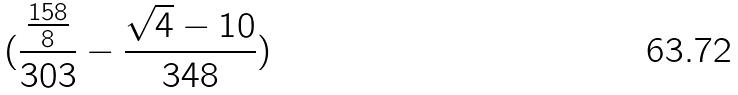Convert formula to latex. <formula><loc_0><loc_0><loc_500><loc_500>( \frac { \frac { 1 5 8 } { 8 } } { 3 0 3 } - \frac { \sqrt { 4 } - 1 0 } { 3 4 8 } )</formula> 